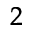<formula> <loc_0><loc_0><loc_500><loc_500>^ { 2 }</formula> 